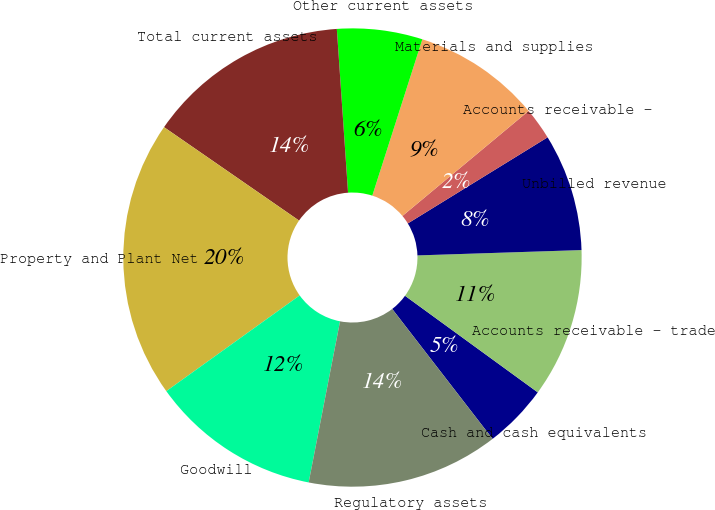Convert chart to OTSL. <chart><loc_0><loc_0><loc_500><loc_500><pie_chart><fcel>Cash and cash equivalents<fcel>Accounts receivable - trade<fcel>Unbilled revenue<fcel>Accounts receivable -<fcel>Materials and supplies<fcel>Other current assets<fcel>Total current assets<fcel>Property and Plant Net<fcel>Goodwill<fcel>Regulatory assets<nl><fcel>4.52%<fcel>10.53%<fcel>8.27%<fcel>2.26%<fcel>9.02%<fcel>6.02%<fcel>14.28%<fcel>19.54%<fcel>12.03%<fcel>13.53%<nl></chart> 